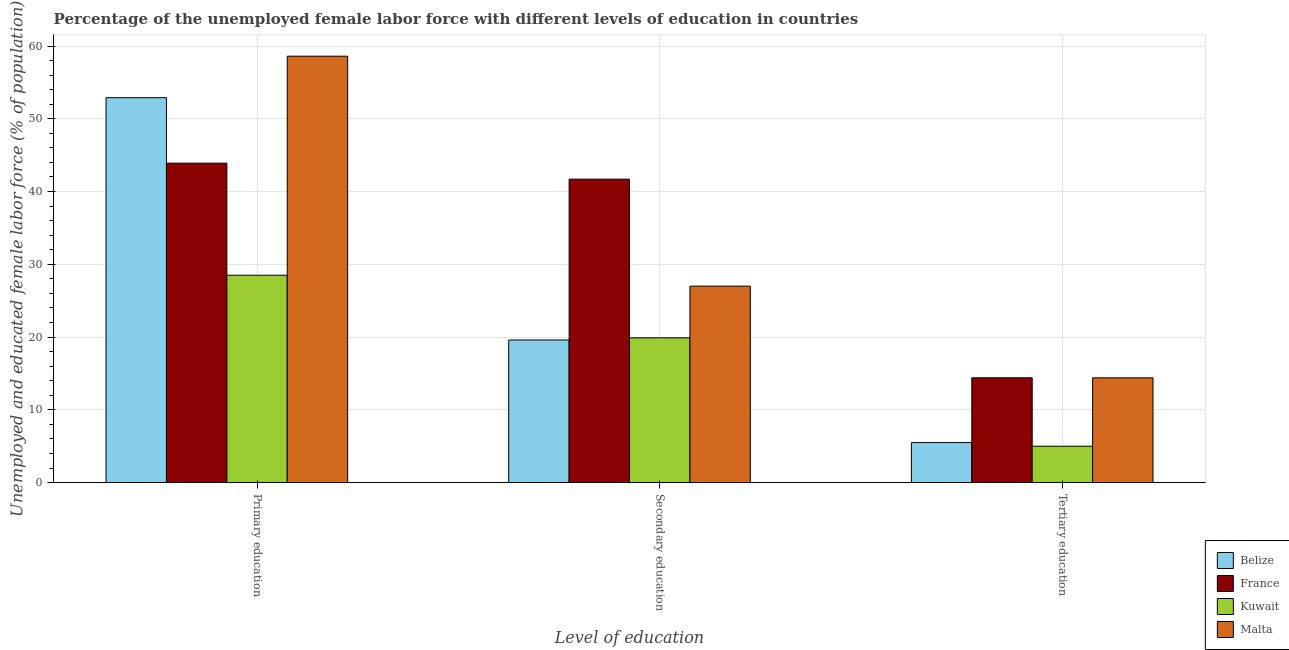How many different coloured bars are there?
Give a very brief answer. 4. Are the number of bars on each tick of the X-axis equal?
Make the answer very short. Yes. Across all countries, what is the maximum percentage of female labor force who received primary education?
Provide a short and direct response. 58.6. Across all countries, what is the minimum percentage of female labor force who received secondary education?
Make the answer very short. 19.6. In which country was the percentage of female labor force who received primary education maximum?
Your response must be concise. Malta. In which country was the percentage of female labor force who received primary education minimum?
Your answer should be very brief. Kuwait. What is the total percentage of female labor force who received primary education in the graph?
Your answer should be compact. 183.9. What is the difference between the percentage of female labor force who received tertiary education in Belize and that in Kuwait?
Make the answer very short. 0.5. What is the difference between the percentage of female labor force who received primary education in France and the percentage of female labor force who received tertiary education in Malta?
Keep it short and to the point. 29.5. What is the average percentage of female labor force who received primary education per country?
Keep it short and to the point. 45.98. In how many countries, is the percentage of female labor force who received tertiary education greater than 30 %?
Keep it short and to the point. 0. What is the ratio of the percentage of female labor force who received secondary education in France to that in Belize?
Offer a very short reply. 2.13. What is the difference between the highest and the second highest percentage of female labor force who received secondary education?
Provide a short and direct response. 14.7. What is the difference between the highest and the lowest percentage of female labor force who received primary education?
Make the answer very short. 30.1. What does the 4th bar from the left in Primary education represents?
Offer a very short reply. Malta. What does the 1st bar from the right in Tertiary education represents?
Give a very brief answer. Malta. How many bars are there?
Your answer should be very brief. 12. Are all the bars in the graph horizontal?
Make the answer very short. No. What is the difference between two consecutive major ticks on the Y-axis?
Your answer should be compact. 10. How many legend labels are there?
Your response must be concise. 4. How are the legend labels stacked?
Offer a very short reply. Vertical. What is the title of the graph?
Provide a succinct answer. Percentage of the unemployed female labor force with different levels of education in countries. Does "Sao Tome and Principe" appear as one of the legend labels in the graph?
Give a very brief answer. No. What is the label or title of the X-axis?
Offer a terse response. Level of education. What is the label or title of the Y-axis?
Your response must be concise. Unemployed and educated female labor force (% of population). What is the Unemployed and educated female labor force (% of population) of Belize in Primary education?
Offer a terse response. 52.9. What is the Unemployed and educated female labor force (% of population) of France in Primary education?
Provide a succinct answer. 43.9. What is the Unemployed and educated female labor force (% of population) of Malta in Primary education?
Ensure brevity in your answer.  58.6. What is the Unemployed and educated female labor force (% of population) of Belize in Secondary education?
Your answer should be compact. 19.6. What is the Unemployed and educated female labor force (% of population) of France in Secondary education?
Offer a very short reply. 41.7. What is the Unemployed and educated female labor force (% of population) in Kuwait in Secondary education?
Your answer should be compact. 19.9. What is the Unemployed and educated female labor force (% of population) in France in Tertiary education?
Your response must be concise. 14.4. What is the Unemployed and educated female labor force (% of population) of Kuwait in Tertiary education?
Your response must be concise. 5. What is the Unemployed and educated female labor force (% of population) of Malta in Tertiary education?
Offer a terse response. 14.4. Across all Level of education, what is the maximum Unemployed and educated female labor force (% of population) in Belize?
Give a very brief answer. 52.9. Across all Level of education, what is the maximum Unemployed and educated female labor force (% of population) in France?
Offer a terse response. 43.9. Across all Level of education, what is the maximum Unemployed and educated female labor force (% of population) of Malta?
Provide a succinct answer. 58.6. Across all Level of education, what is the minimum Unemployed and educated female labor force (% of population) in France?
Offer a very short reply. 14.4. Across all Level of education, what is the minimum Unemployed and educated female labor force (% of population) in Kuwait?
Provide a short and direct response. 5. Across all Level of education, what is the minimum Unemployed and educated female labor force (% of population) in Malta?
Keep it short and to the point. 14.4. What is the total Unemployed and educated female labor force (% of population) of Kuwait in the graph?
Offer a very short reply. 53.4. What is the difference between the Unemployed and educated female labor force (% of population) of Belize in Primary education and that in Secondary education?
Your answer should be compact. 33.3. What is the difference between the Unemployed and educated female labor force (% of population) of Kuwait in Primary education and that in Secondary education?
Give a very brief answer. 8.6. What is the difference between the Unemployed and educated female labor force (% of population) of Malta in Primary education and that in Secondary education?
Your answer should be compact. 31.6. What is the difference between the Unemployed and educated female labor force (% of population) in Belize in Primary education and that in Tertiary education?
Offer a terse response. 47.4. What is the difference between the Unemployed and educated female labor force (% of population) of France in Primary education and that in Tertiary education?
Offer a terse response. 29.5. What is the difference between the Unemployed and educated female labor force (% of population) in Kuwait in Primary education and that in Tertiary education?
Provide a succinct answer. 23.5. What is the difference between the Unemployed and educated female labor force (% of population) in Malta in Primary education and that in Tertiary education?
Provide a short and direct response. 44.2. What is the difference between the Unemployed and educated female labor force (% of population) of Belize in Secondary education and that in Tertiary education?
Your answer should be very brief. 14.1. What is the difference between the Unemployed and educated female labor force (% of population) of France in Secondary education and that in Tertiary education?
Offer a very short reply. 27.3. What is the difference between the Unemployed and educated female labor force (% of population) of Malta in Secondary education and that in Tertiary education?
Offer a terse response. 12.6. What is the difference between the Unemployed and educated female labor force (% of population) in Belize in Primary education and the Unemployed and educated female labor force (% of population) in France in Secondary education?
Your response must be concise. 11.2. What is the difference between the Unemployed and educated female labor force (% of population) of Belize in Primary education and the Unemployed and educated female labor force (% of population) of Kuwait in Secondary education?
Your answer should be very brief. 33. What is the difference between the Unemployed and educated female labor force (% of population) in Belize in Primary education and the Unemployed and educated female labor force (% of population) in Malta in Secondary education?
Your answer should be very brief. 25.9. What is the difference between the Unemployed and educated female labor force (% of population) of France in Primary education and the Unemployed and educated female labor force (% of population) of Malta in Secondary education?
Make the answer very short. 16.9. What is the difference between the Unemployed and educated female labor force (% of population) of Belize in Primary education and the Unemployed and educated female labor force (% of population) of France in Tertiary education?
Ensure brevity in your answer.  38.5. What is the difference between the Unemployed and educated female labor force (% of population) in Belize in Primary education and the Unemployed and educated female labor force (% of population) in Kuwait in Tertiary education?
Your response must be concise. 47.9. What is the difference between the Unemployed and educated female labor force (% of population) in Belize in Primary education and the Unemployed and educated female labor force (% of population) in Malta in Tertiary education?
Make the answer very short. 38.5. What is the difference between the Unemployed and educated female labor force (% of population) of France in Primary education and the Unemployed and educated female labor force (% of population) of Kuwait in Tertiary education?
Your response must be concise. 38.9. What is the difference between the Unemployed and educated female labor force (% of population) of France in Primary education and the Unemployed and educated female labor force (% of population) of Malta in Tertiary education?
Ensure brevity in your answer.  29.5. What is the difference between the Unemployed and educated female labor force (% of population) of Belize in Secondary education and the Unemployed and educated female labor force (% of population) of France in Tertiary education?
Provide a short and direct response. 5.2. What is the difference between the Unemployed and educated female labor force (% of population) in France in Secondary education and the Unemployed and educated female labor force (% of population) in Kuwait in Tertiary education?
Make the answer very short. 36.7. What is the difference between the Unemployed and educated female labor force (% of population) in France in Secondary education and the Unemployed and educated female labor force (% of population) in Malta in Tertiary education?
Your response must be concise. 27.3. What is the average Unemployed and educated female labor force (% of population) in France per Level of education?
Offer a very short reply. 33.33. What is the average Unemployed and educated female labor force (% of population) in Malta per Level of education?
Give a very brief answer. 33.33. What is the difference between the Unemployed and educated female labor force (% of population) in Belize and Unemployed and educated female labor force (% of population) in France in Primary education?
Give a very brief answer. 9. What is the difference between the Unemployed and educated female labor force (% of population) of Belize and Unemployed and educated female labor force (% of population) of Kuwait in Primary education?
Offer a very short reply. 24.4. What is the difference between the Unemployed and educated female labor force (% of population) in Belize and Unemployed and educated female labor force (% of population) in Malta in Primary education?
Give a very brief answer. -5.7. What is the difference between the Unemployed and educated female labor force (% of population) of France and Unemployed and educated female labor force (% of population) of Malta in Primary education?
Offer a terse response. -14.7. What is the difference between the Unemployed and educated female labor force (% of population) in Kuwait and Unemployed and educated female labor force (% of population) in Malta in Primary education?
Provide a succinct answer. -30.1. What is the difference between the Unemployed and educated female labor force (% of population) in Belize and Unemployed and educated female labor force (% of population) in France in Secondary education?
Your response must be concise. -22.1. What is the difference between the Unemployed and educated female labor force (% of population) in Belize and Unemployed and educated female labor force (% of population) in Kuwait in Secondary education?
Offer a terse response. -0.3. What is the difference between the Unemployed and educated female labor force (% of population) of France and Unemployed and educated female labor force (% of population) of Kuwait in Secondary education?
Make the answer very short. 21.8. What is the difference between the Unemployed and educated female labor force (% of population) in France and Unemployed and educated female labor force (% of population) in Malta in Secondary education?
Make the answer very short. 14.7. What is the difference between the Unemployed and educated female labor force (% of population) of Belize and Unemployed and educated female labor force (% of population) of France in Tertiary education?
Offer a terse response. -8.9. What is the difference between the Unemployed and educated female labor force (% of population) in Belize and Unemployed and educated female labor force (% of population) in Malta in Tertiary education?
Offer a very short reply. -8.9. What is the difference between the Unemployed and educated female labor force (% of population) in France and Unemployed and educated female labor force (% of population) in Kuwait in Tertiary education?
Offer a very short reply. 9.4. What is the difference between the Unemployed and educated female labor force (% of population) in Kuwait and Unemployed and educated female labor force (% of population) in Malta in Tertiary education?
Your answer should be very brief. -9.4. What is the ratio of the Unemployed and educated female labor force (% of population) in Belize in Primary education to that in Secondary education?
Offer a very short reply. 2.7. What is the ratio of the Unemployed and educated female labor force (% of population) in France in Primary education to that in Secondary education?
Offer a terse response. 1.05. What is the ratio of the Unemployed and educated female labor force (% of population) of Kuwait in Primary education to that in Secondary education?
Provide a short and direct response. 1.43. What is the ratio of the Unemployed and educated female labor force (% of population) of Malta in Primary education to that in Secondary education?
Your response must be concise. 2.17. What is the ratio of the Unemployed and educated female labor force (% of population) in Belize in Primary education to that in Tertiary education?
Provide a short and direct response. 9.62. What is the ratio of the Unemployed and educated female labor force (% of population) in France in Primary education to that in Tertiary education?
Your response must be concise. 3.05. What is the ratio of the Unemployed and educated female labor force (% of population) of Kuwait in Primary education to that in Tertiary education?
Ensure brevity in your answer.  5.7. What is the ratio of the Unemployed and educated female labor force (% of population) in Malta in Primary education to that in Tertiary education?
Your response must be concise. 4.07. What is the ratio of the Unemployed and educated female labor force (% of population) in Belize in Secondary education to that in Tertiary education?
Your response must be concise. 3.56. What is the ratio of the Unemployed and educated female labor force (% of population) in France in Secondary education to that in Tertiary education?
Give a very brief answer. 2.9. What is the ratio of the Unemployed and educated female labor force (% of population) of Kuwait in Secondary education to that in Tertiary education?
Your answer should be compact. 3.98. What is the ratio of the Unemployed and educated female labor force (% of population) in Malta in Secondary education to that in Tertiary education?
Make the answer very short. 1.88. What is the difference between the highest and the second highest Unemployed and educated female labor force (% of population) of Belize?
Provide a short and direct response. 33.3. What is the difference between the highest and the second highest Unemployed and educated female labor force (% of population) in Malta?
Your answer should be compact. 31.6. What is the difference between the highest and the lowest Unemployed and educated female labor force (% of population) of Belize?
Give a very brief answer. 47.4. What is the difference between the highest and the lowest Unemployed and educated female labor force (% of population) of France?
Your answer should be compact. 29.5. What is the difference between the highest and the lowest Unemployed and educated female labor force (% of population) of Malta?
Make the answer very short. 44.2. 